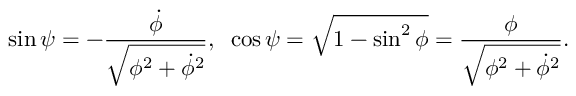Convert formula to latex. <formula><loc_0><loc_0><loc_500><loc_500>\sin { \psi } = - \frac { \dot { \phi } } { \sqrt { \phi ^ { 2 } + \dot { \phi } ^ { 2 } } } , \, \cos { \psi } = \sqrt { 1 - \sin ^ { 2 } { \phi } } = \frac { \phi } { \sqrt { \phi ^ { 2 } + \dot { \phi } ^ { 2 } } } .</formula> 